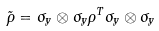Convert formula to latex. <formula><loc_0><loc_0><loc_500><loc_500>\tilde { \rho } = \sigma _ { y } \otimes \sigma _ { y } \rho ^ { T } \sigma _ { y } \otimes \sigma _ { y }</formula> 